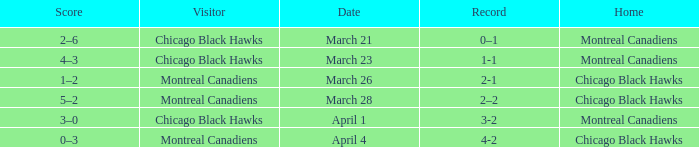What is the team's score with a 2-1 performance? 1–2. 